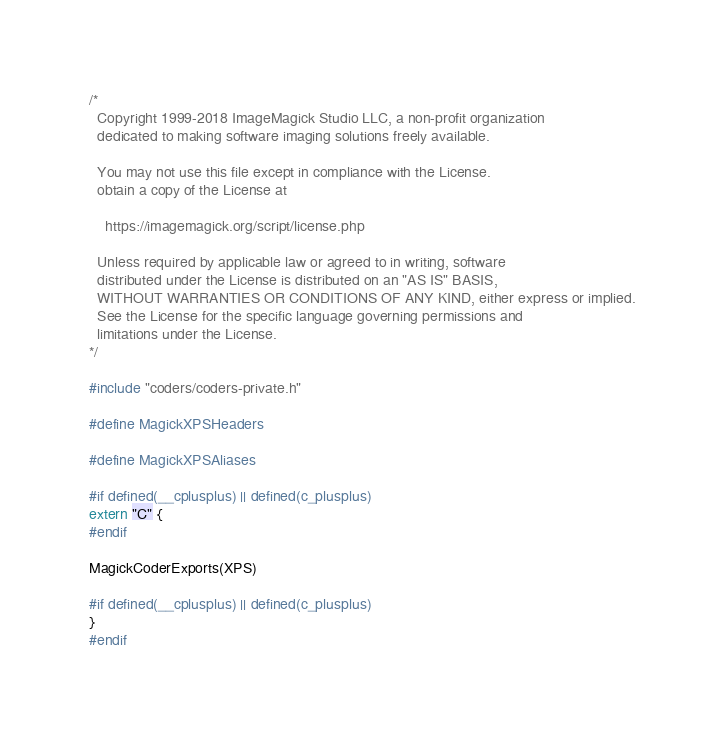Convert code to text. <code><loc_0><loc_0><loc_500><loc_500><_C_>/*
  Copyright 1999-2018 ImageMagick Studio LLC, a non-profit organization
  dedicated to making software imaging solutions freely available.
  
  You may not use this file except in compliance with the License.
  obtain a copy of the License at
  
    https://imagemagick.org/script/license.php
  
  Unless required by applicable law or agreed to in writing, software
  distributed under the License is distributed on an "AS IS" BASIS,
  WITHOUT WARRANTIES OR CONDITIONS OF ANY KIND, either express or implied.
  See the License for the specific language governing permissions and
  limitations under the License.
*/

#include "coders/coders-private.h"

#define MagickXPSHeaders

#define MagickXPSAliases

#if defined(__cplusplus) || defined(c_plusplus)
extern "C" {
#endif

MagickCoderExports(XPS)

#if defined(__cplusplus) || defined(c_plusplus)
}
#endif</code> 